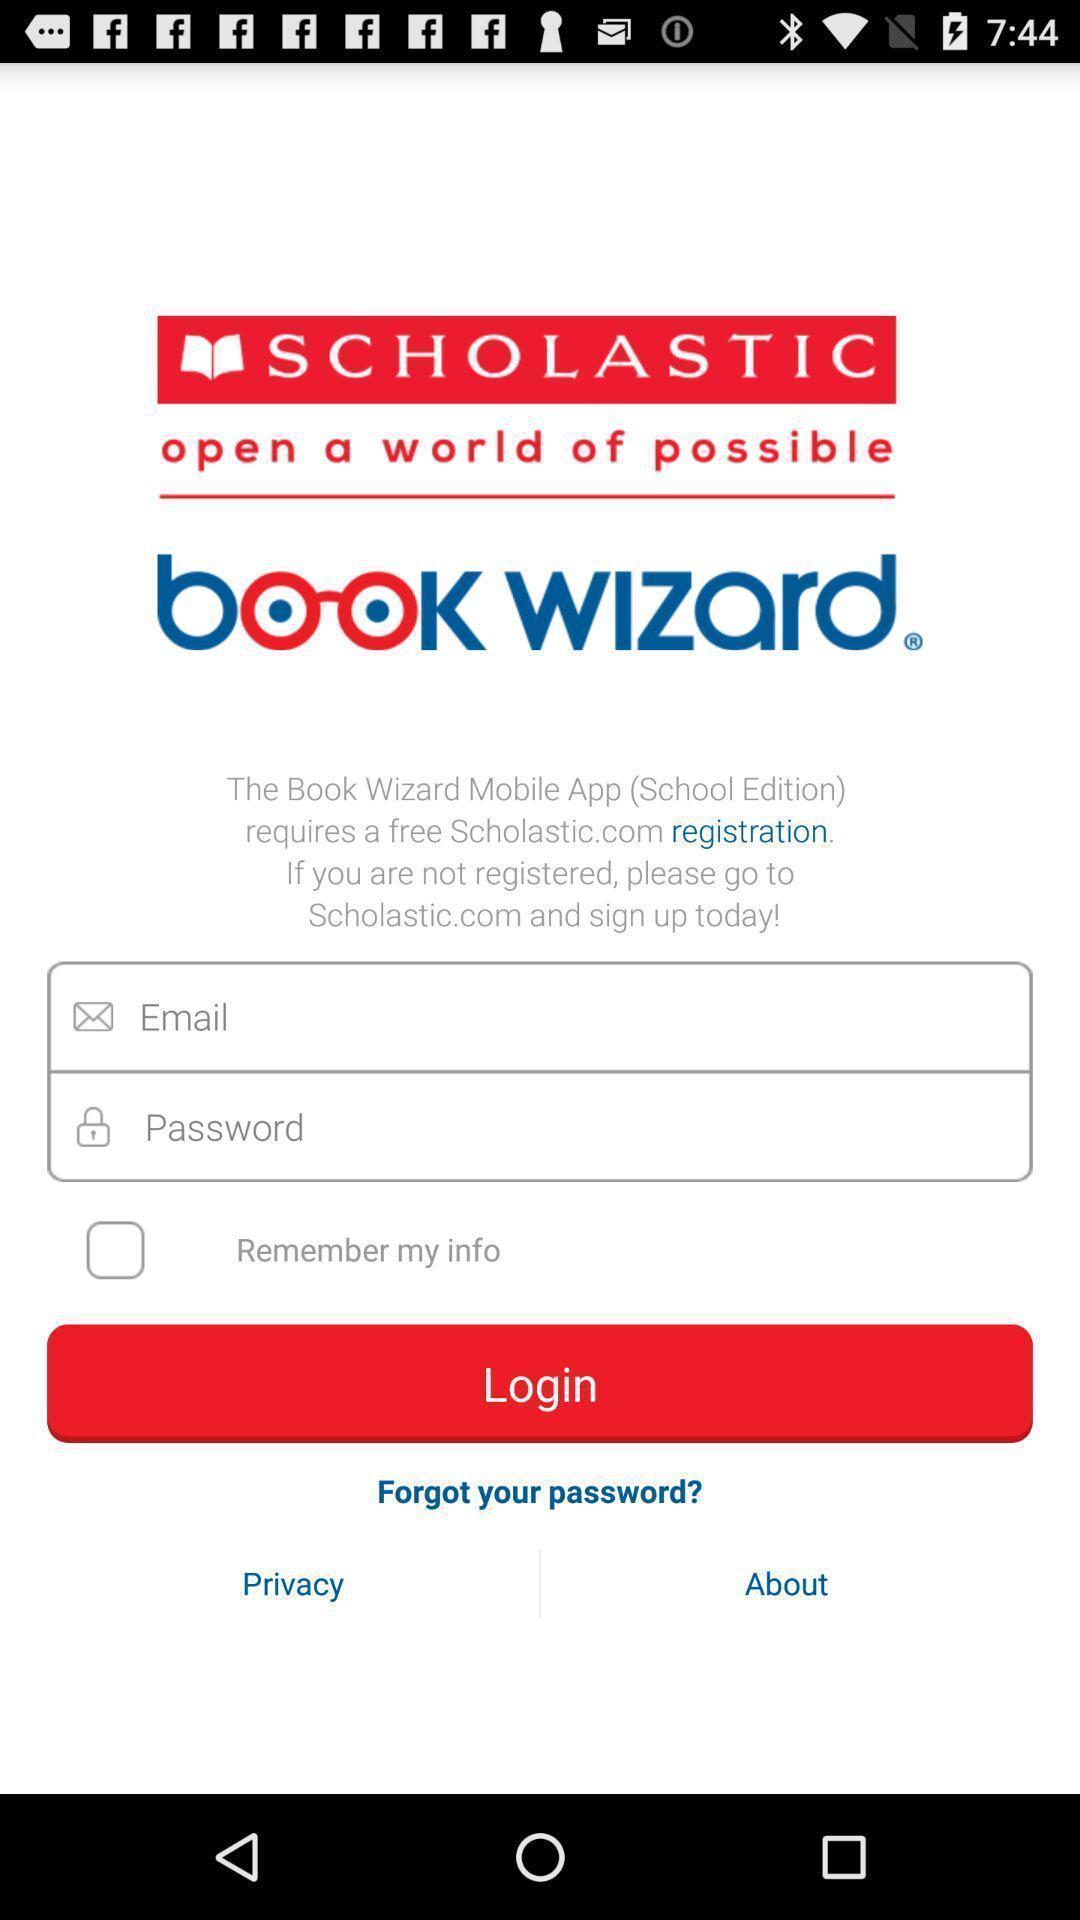What is the overall content of this screenshot? Welcome screen for a education related app. 